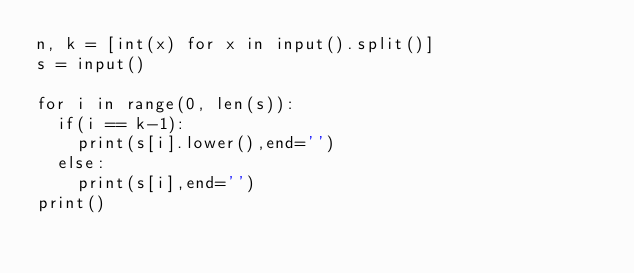Convert code to text. <code><loc_0><loc_0><loc_500><loc_500><_Python_>n, k = [int(x) for x in input().split()]
s = input()

for i in range(0, len(s)):
  if(i == k-1):
    print(s[i].lower(),end='')
  else:
    print(s[i],end='')
print()

</code> 